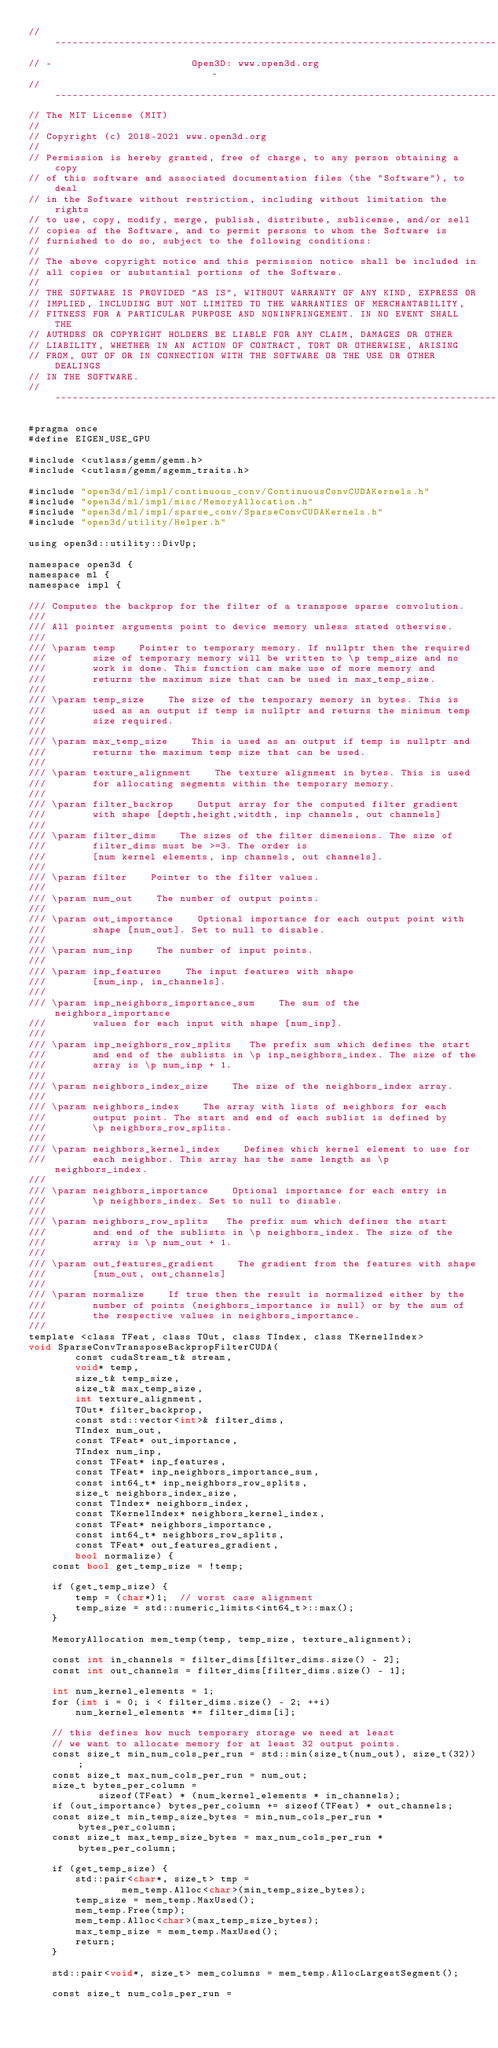<code> <loc_0><loc_0><loc_500><loc_500><_Cuda_>// ----------------------------------------------------------------------------
// -                        Open3D: www.open3d.org                            -
// ----------------------------------------------------------------------------
// The MIT License (MIT)
//
// Copyright (c) 2018-2021 www.open3d.org
//
// Permission is hereby granted, free of charge, to any person obtaining a copy
// of this software and associated documentation files (the "Software"), to deal
// in the Software without restriction, including without limitation the rights
// to use, copy, modify, merge, publish, distribute, sublicense, and/or sell
// copies of the Software, and to permit persons to whom the Software is
// furnished to do so, subject to the following conditions:
//
// The above copyright notice and this permission notice shall be included in
// all copies or substantial portions of the Software.
//
// THE SOFTWARE IS PROVIDED "AS IS", WITHOUT WARRANTY OF ANY KIND, EXPRESS OR
// IMPLIED, INCLUDING BUT NOT LIMITED TO THE WARRANTIES OF MERCHANTABILITY,
// FITNESS FOR A PARTICULAR PURPOSE AND NONINFRINGEMENT. IN NO EVENT SHALL THE
// AUTHORS OR COPYRIGHT HOLDERS BE LIABLE FOR ANY CLAIM, DAMAGES OR OTHER
// LIABILITY, WHETHER IN AN ACTION OF CONTRACT, TORT OR OTHERWISE, ARISING
// FROM, OUT OF OR IN CONNECTION WITH THE SOFTWARE OR THE USE OR OTHER DEALINGS
// IN THE SOFTWARE.
// ----------------------------------------------------------------------------

#pragma once
#define EIGEN_USE_GPU

#include <cutlass/gemm/gemm.h>
#include <cutlass/gemm/sgemm_traits.h>

#include "open3d/ml/impl/continuous_conv/ContinuousConvCUDAKernels.h"
#include "open3d/ml/impl/misc/MemoryAllocation.h"
#include "open3d/ml/impl/sparse_conv/SparseConvCUDAKernels.h"
#include "open3d/utility/Helper.h"

using open3d::utility::DivUp;

namespace open3d {
namespace ml {
namespace impl {

/// Computes the backprop for the filter of a transpose sparse convolution.
///
/// All pointer arguments point to device memory unless stated otherwise.
///
/// \param temp    Pointer to temporary memory. If nullptr then the required
///        size of temporary memory will be written to \p temp_size and no
///        work is done. This function can make use of more memory and
///        returns the maximum size that can be used in max_temp_size.
///
/// \param temp_size    The size of the temporary memory in bytes. This is
///        used as an output if temp is nullptr and returns the minimum temp
///        size required.
///
/// \param max_temp_size    This is used as an output if temp is nullptr and
///        returns the maximum temp size that can be used.
///
/// \param texture_alignment    The texture alignment in bytes. This is used
///        for allocating segments within the temporary memory.
///
/// \param filter_backrop    Output array for the computed filter gradient
///        with shape [depth,height,witdth, inp channels, out channels]
///
/// \param filter_dims    The sizes of the filter dimensions. The size of
///        filter_dims must be >=3. The order is
///        [num kernel elements, inp channels, out channels].
///
/// \param filter    Pointer to the filter values.
///
/// \param num_out    The number of output points.
///
/// \param out_importance    Optional importance for each output point with
///        shape [num_out]. Set to null to disable.
///
/// \param num_inp    The number of input points.
///
/// \param inp_features    The input features with shape
///        [num_inp, in_channels].
///
/// \param inp_neighbors_importance_sum    The sum of the neighbors_importance
///        values for each input with shape [num_inp].
///
/// \param inp_neighbors_row_splits   The prefix sum which defines the start
///        and end of the sublists in \p inp_neighbors_index. The size of the
///        array is \p num_inp + 1.
///
/// \param neighbors_index_size    The size of the neighbors_index array.
///
/// \param neighbors_index    The array with lists of neighbors for each
///        output point. The start and end of each sublist is defined by
///        \p neighbors_row_splits.
///
/// \param neighbors_kernel_index    Defines which kernel element to use for
///        each neighbor. This array has the same length as \p neighbors_index.
///
/// \param neighbors_importance    Optional importance for each entry in
///        \p neighbors_index. Set to null to disable.
///
/// \param neighbors_row_splits   The prefix sum which defines the start
///        and end of the sublists in \p neighbors_index. The size of the
///        array is \p num_out + 1.
///
/// \param out_features_gradient    The gradient from the features with shape
///        [num_out, out_channels]
///
/// \param normalize    If true then the result is normalized either by the
///        number of points (neighbors_importance is null) or by the sum of
///        the respective values in neighbors_importance.
///
template <class TFeat, class TOut, class TIndex, class TKernelIndex>
void SparseConvTransposeBackpropFilterCUDA(
        const cudaStream_t& stream,
        void* temp,
        size_t& temp_size,
        size_t& max_temp_size,
        int texture_alignment,
        TOut* filter_backprop,
        const std::vector<int>& filter_dims,
        TIndex num_out,
        const TFeat* out_importance,
        TIndex num_inp,
        const TFeat* inp_features,
        const TFeat* inp_neighbors_importance_sum,
        const int64_t* inp_neighbors_row_splits,
        size_t neighbors_index_size,
        const TIndex* neighbors_index,
        const TKernelIndex* neighbors_kernel_index,
        const TFeat* neighbors_importance,
        const int64_t* neighbors_row_splits,
        const TFeat* out_features_gradient,
        bool normalize) {
    const bool get_temp_size = !temp;

    if (get_temp_size) {
        temp = (char*)1;  // worst case alignment
        temp_size = std::numeric_limits<int64_t>::max();
    }

    MemoryAllocation mem_temp(temp, temp_size, texture_alignment);

    const int in_channels = filter_dims[filter_dims.size() - 2];
    const int out_channels = filter_dims[filter_dims.size() - 1];

    int num_kernel_elements = 1;
    for (int i = 0; i < filter_dims.size() - 2; ++i)
        num_kernel_elements *= filter_dims[i];

    // this defines how much temporary storage we need at least
    // we want to allocate memory for at least 32 output points.
    const size_t min_num_cols_per_run = std::min(size_t(num_out), size_t(32));
    const size_t max_num_cols_per_run = num_out;
    size_t bytes_per_column =
            sizeof(TFeat) * (num_kernel_elements * in_channels);
    if (out_importance) bytes_per_column += sizeof(TFeat) * out_channels;
    const size_t min_temp_size_bytes = min_num_cols_per_run * bytes_per_column;
    const size_t max_temp_size_bytes = max_num_cols_per_run * bytes_per_column;

    if (get_temp_size) {
        std::pair<char*, size_t> tmp =
                mem_temp.Alloc<char>(min_temp_size_bytes);
        temp_size = mem_temp.MaxUsed();
        mem_temp.Free(tmp);
        mem_temp.Alloc<char>(max_temp_size_bytes);
        max_temp_size = mem_temp.MaxUsed();
        return;
    }

    std::pair<void*, size_t> mem_columns = mem_temp.AllocLargestSegment();

    const size_t num_cols_per_run =</code> 